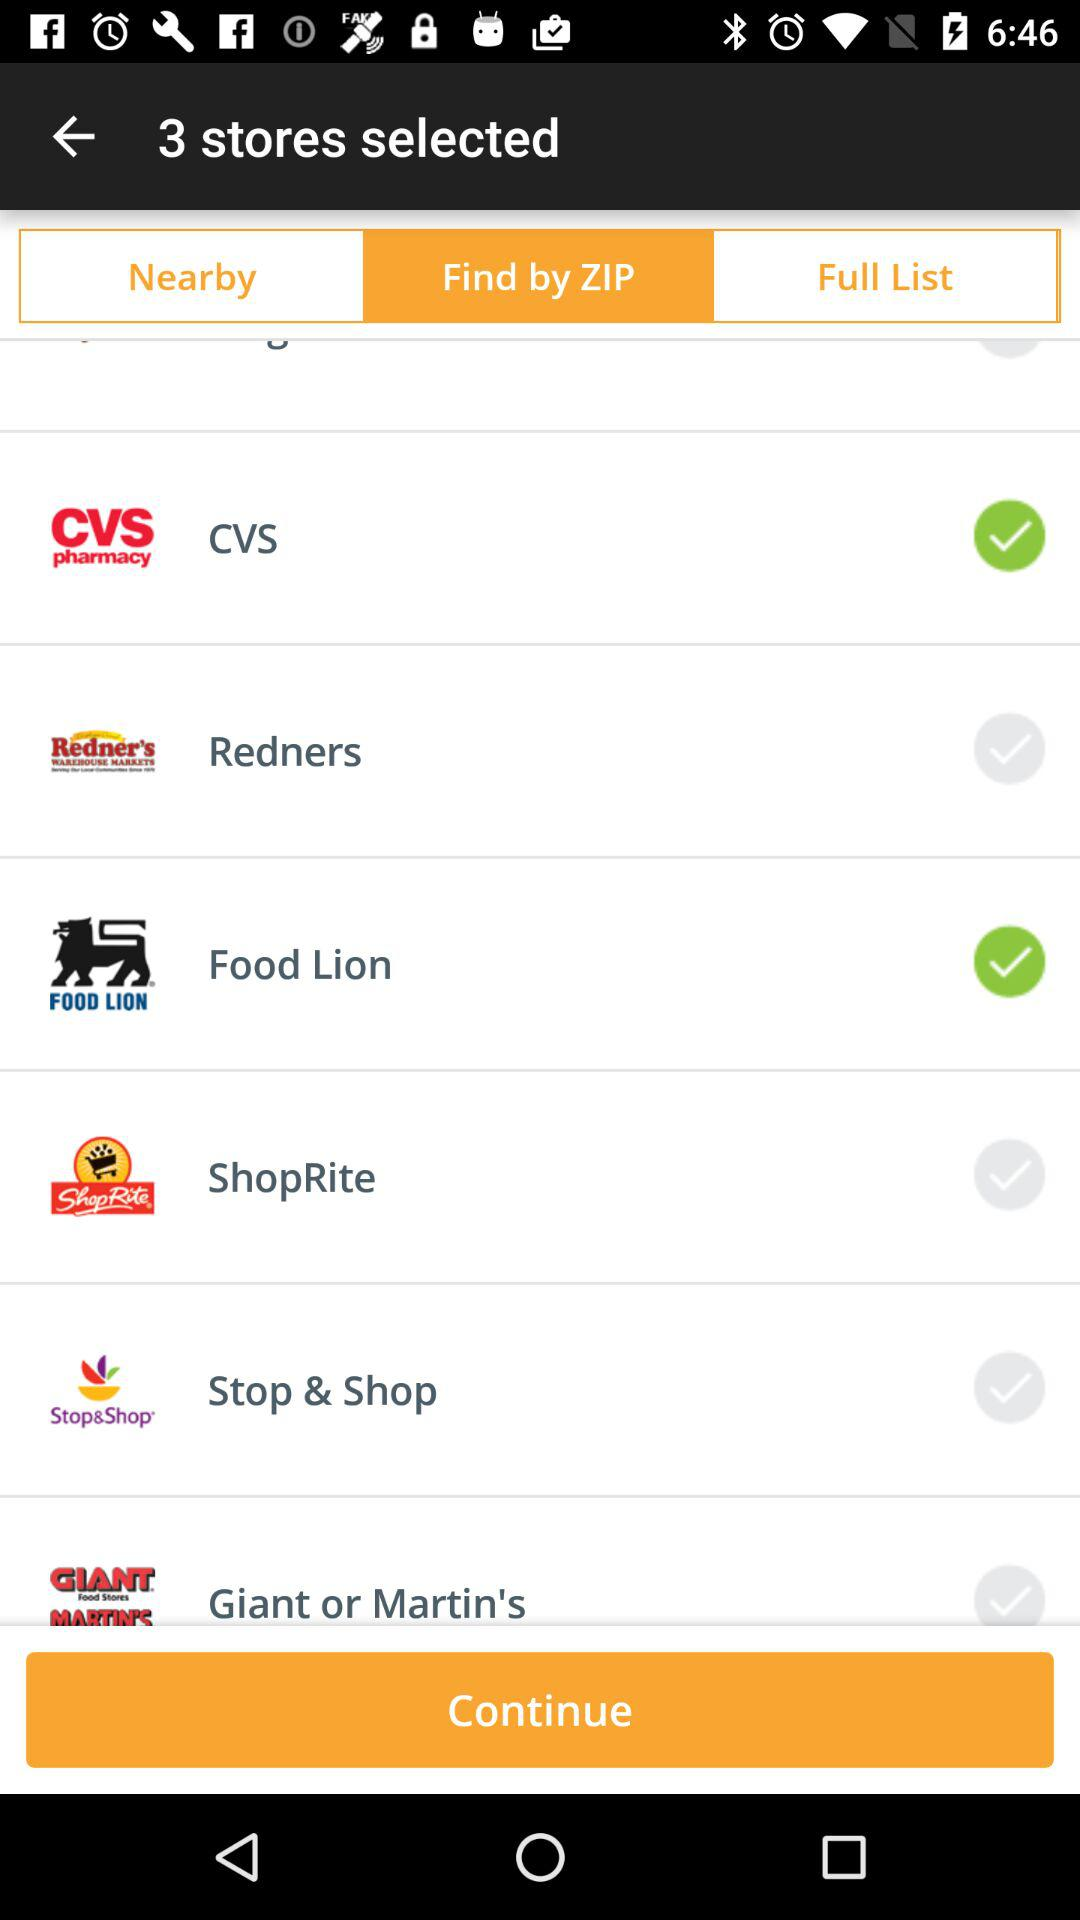What is the status of "Stop & shop"? The status of "Stop & shop" is not selected. 